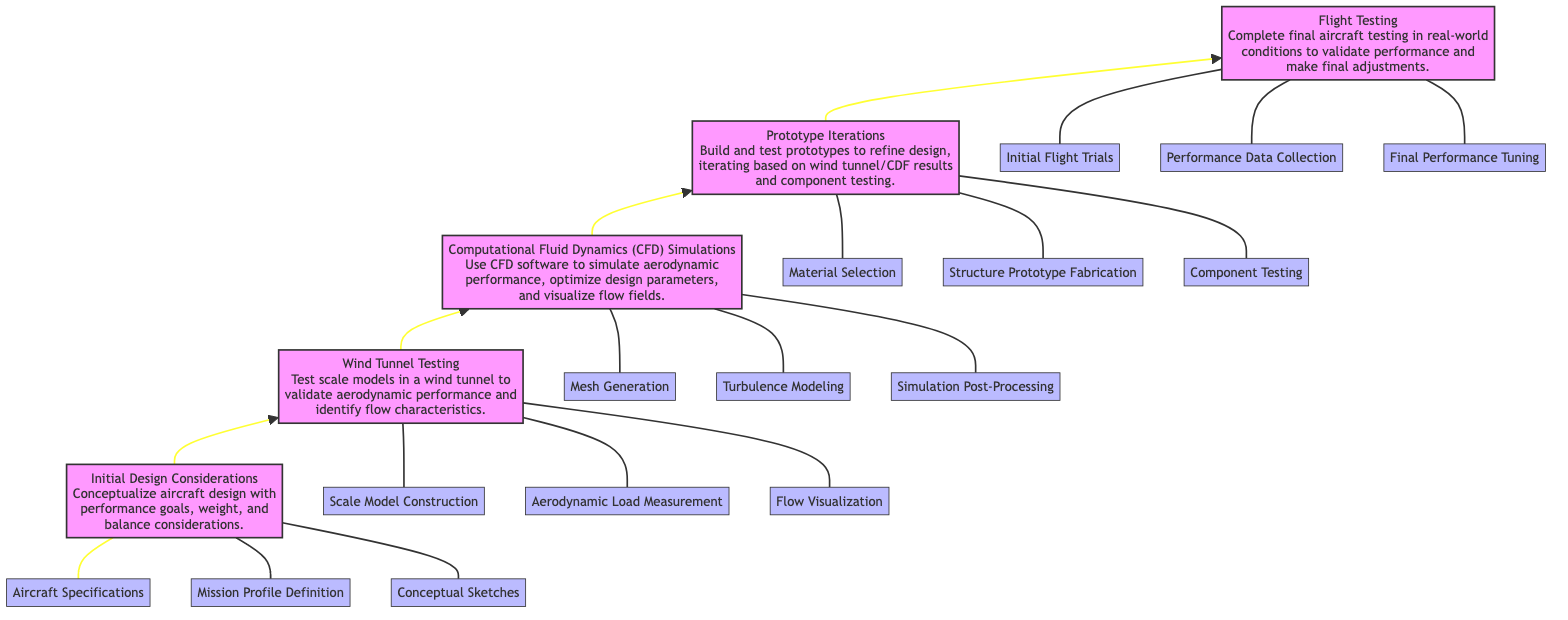What is the first stage in the performance optimization process? The diagram lists "Initial Design Considerations" as the first stage, positioned at the bottom and highlighted as the starting point for optimization.
Answer: Initial Design Considerations How many stages are there in total? By counting the nodes in the diagram, there are five distinct stages indicated, from the bottom to the top of the flow chart.
Answer: 5 What stage follows Wind Tunnel Testing? According to the flow depicted, "Computational Fluid Dynamics (CFD) Simulations" directly follows "Wind Tunnel Testing," indicating the next step in the optimization process.
Answer: Computational Fluid Dynamics (CFD) Simulations Which stage involves "Prototype Iterations"? The label "Prototype Iterations" identifies a specific stage in the diagram; it is placed above "Computational Fluid Dynamics (CFD) Simulations" in the upward flow.
Answer: Prototype Iterations What specific testing activities are included in Flight Testing? The flow shows three activities associated with Flight Testing: "Initial Flight Trials," "Performance Data Collection," and "Final Performance Tuning," indicating the comprehensive testing activities involved in this stage.
Answer: Initial Flight Trials, Performance Data Collection, Final Performance Tuning Which design consideration stage involves Aerodynamic Load Measurement? "Aerodynamic Load Measurement" is listed as an example of "Wind Tunnel Testing;" therefore, this stage encompasses that specific design consideration activity.
Answer: Wind Tunnel Testing What is the primary purpose of the "Computational Fluid Dynamics (CFD) Simulations" stage? In the diagram, the description for this stage states that its primary purpose is to use CFD software to simulate aerodynamic performance and optimize design parameters, emphasizing its role in performance analysis.
Answer: Simulate aerodynamic performance Name one activity from the "Prototype Iterations" stage. The example activities listed for "Prototype Iterations" include "Material Selection," which is a specific task undertaken during this stage of development.
Answer: Material Selection How do the stages progress according to the flow chart? The chart illustrates a bottom-to-top flow, indicating that the stages progress sequentially upward from "Initial Design Considerations" to "Flight Testing."
Answer: Sequentially upward 